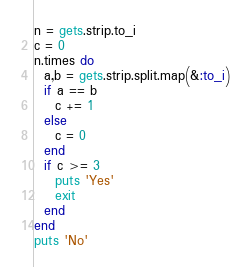Convert code to text. <code><loc_0><loc_0><loc_500><loc_500><_Ruby_>n = gets.strip.to_i
c = 0
n.times do
  a,b = gets.strip.split.map(&:to_i)
  if a == b
    c += 1
  else
    c = 0
  end
  if c >= 3
    puts 'Yes'
    exit
  end
end
puts 'No'
</code> 